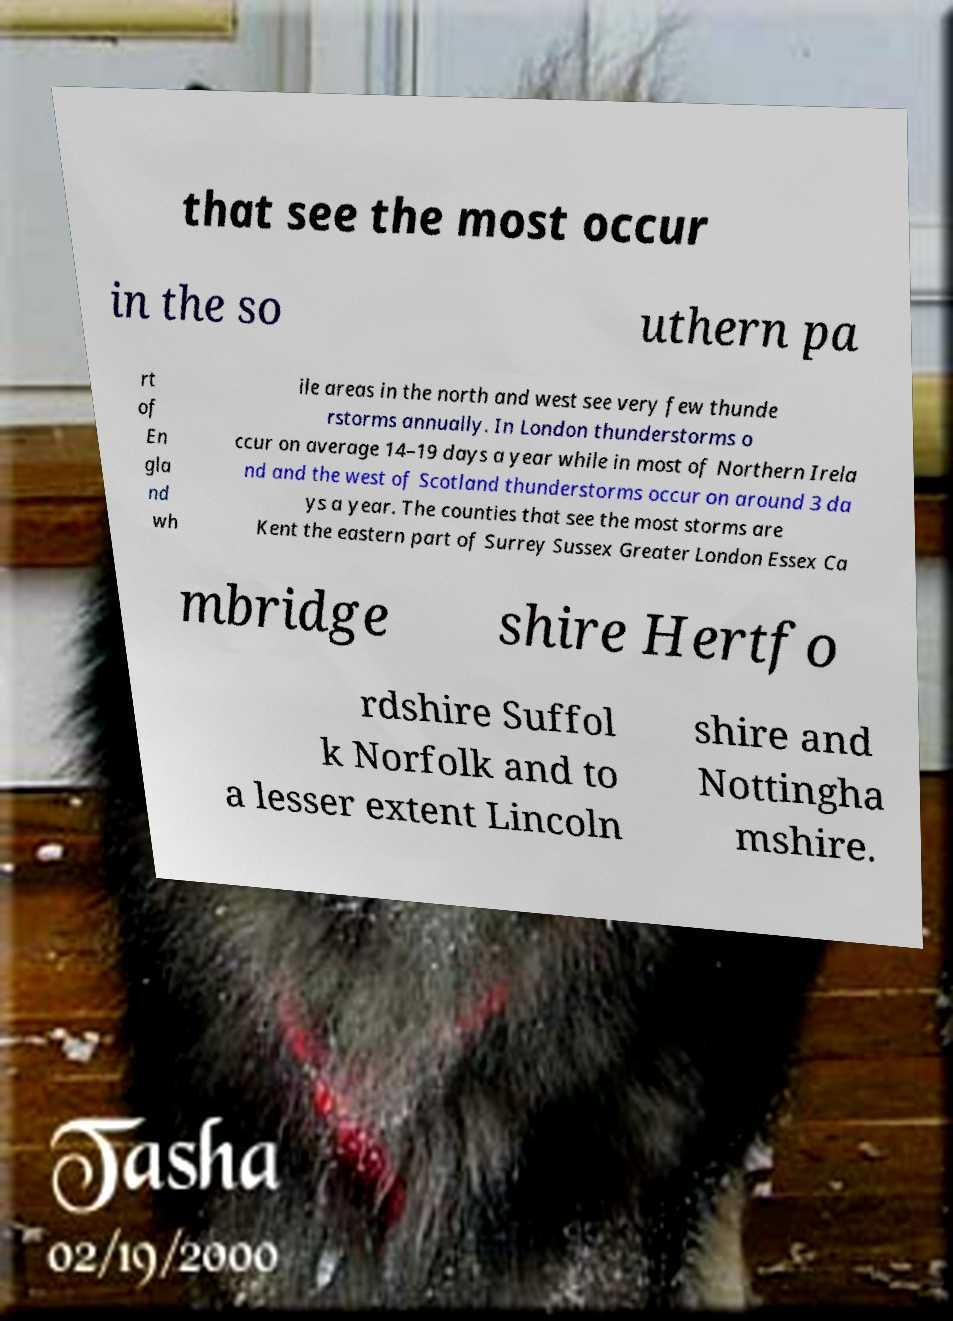What messages or text are displayed in this image? I need them in a readable, typed format. that see the most occur in the so uthern pa rt of En gla nd wh ile areas in the north and west see very few thunde rstorms annually. In London thunderstorms o ccur on average 14–19 days a year while in most of Northern Irela nd and the west of Scotland thunderstorms occur on around 3 da ys a year. The counties that see the most storms are Kent the eastern part of Surrey Sussex Greater London Essex Ca mbridge shire Hertfo rdshire Suffol k Norfolk and to a lesser extent Lincoln shire and Nottingha mshire. 